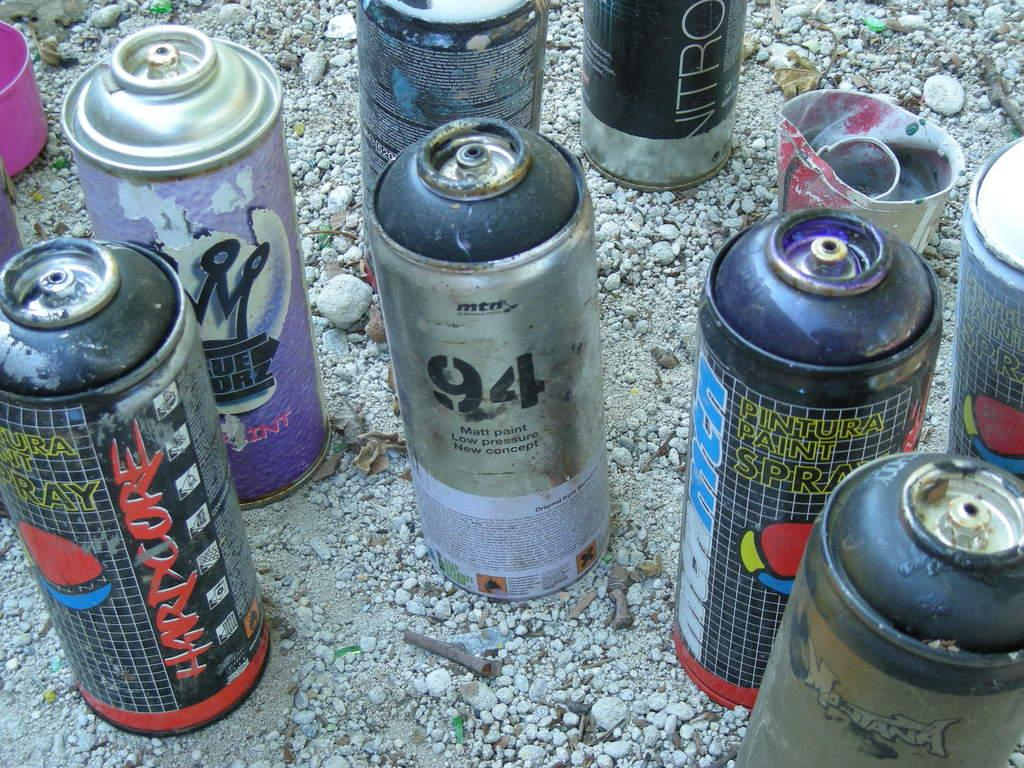What type of objects are present in the image? There are spray bottles in the image. Can you describe the appearance of the spray bottles? The spray bottles have different colors. How many tomatoes are on the table in the image? There are no tomatoes present in the image; it only features spray bottles. What type of magic is being performed with the spray bottles in the image? There is no magic being performed in the image; it simply shows spray bottles with different colors. 